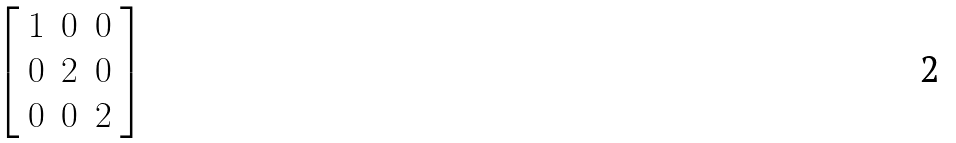Convert formula to latex. <formula><loc_0><loc_0><loc_500><loc_500>\left [ \begin{array} { l l l } { 1 } & { 0 } & { 0 } \\ { 0 } & { 2 } & { 0 } \\ { 0 } & { 0 } & { 2 } \end{array} \right ]</formula> 